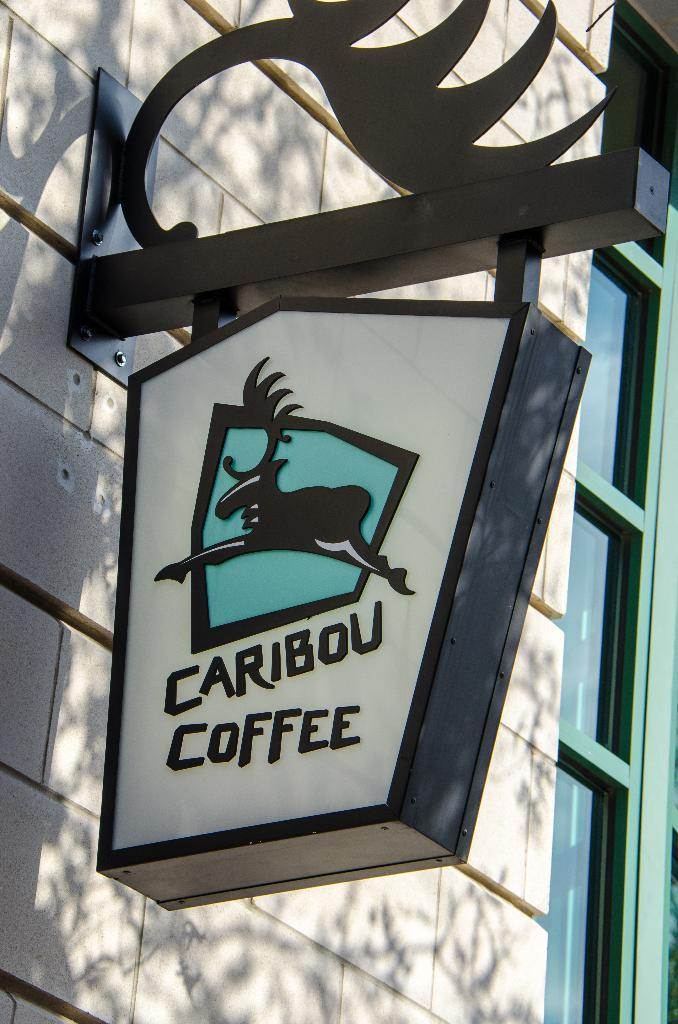What is attached to the wall in the image? There is a board attached to the wall in the image. Can you describe the location of the board in relation to other elements in the image? The board is in front of a window in the image. What type of train can be seen passing by the window in the image? There is no train visible in the image; it only features a board attached to the wall and a window behind it. 